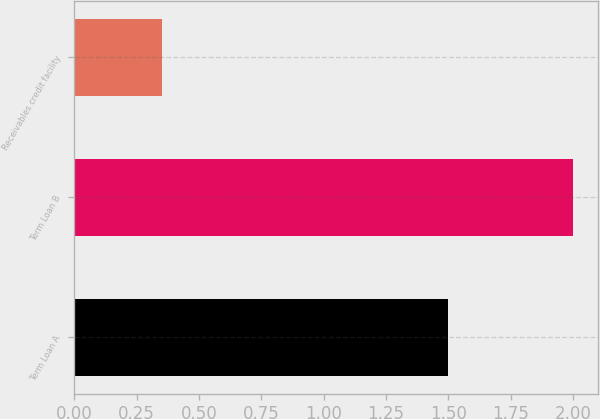Convert chart to OTSL. <chart><loc_0><loc_0><loc_500><loc_500><bar_chart><fcel>Term Loan A<fcel>Term Loan B<fcel>Receivables credit facility<nl><fcel>1.5<fcel>2<fcel>0.35<nl></chart> 